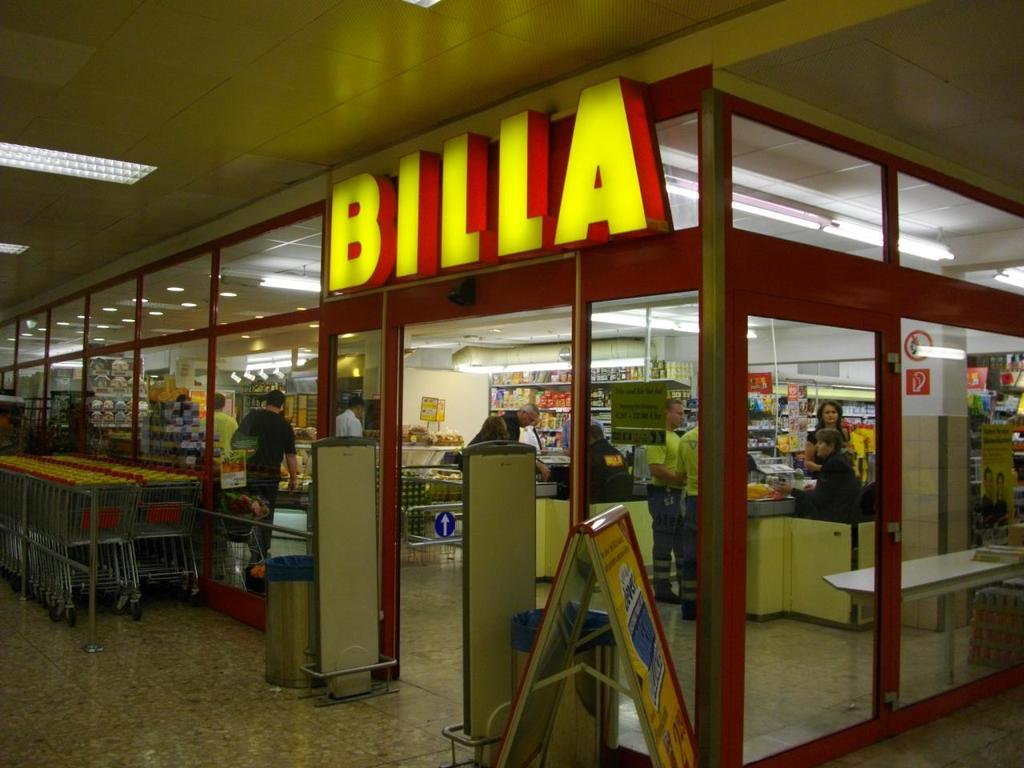<image>
Relay a brief, clear account of the picture shown. Several shopping carts are outside of a store called Billa. 